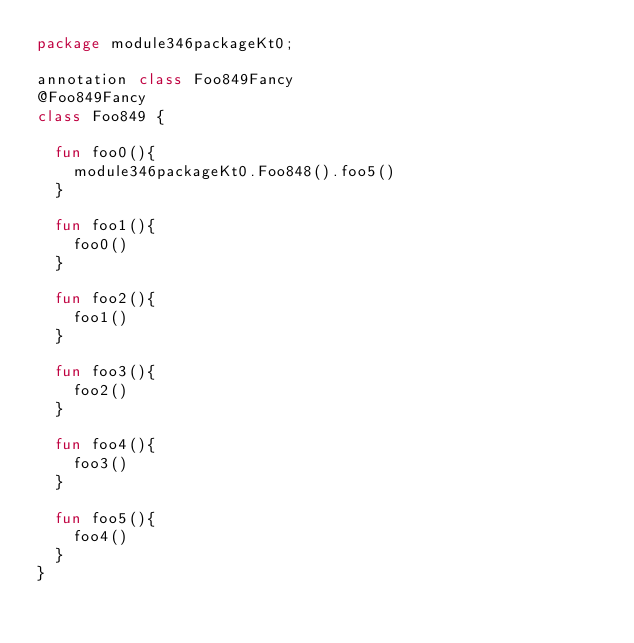<code> <loc_0><loc_0><loc_500><loc_500><_Kotlin_>package module346packageKt0;

annotation class Foo849Fancy
@Foo849Fancy
class Foo849 {

  fun foo0(){
    module346packageKt0.Foo848().foo5()
  }

  fun foo1(){
    foo0()
  }

  fun foo2(){
    foo1()
  }

  fun foo3(){
    foo2()
  }

  fun foo4(){
    foo3()
  }

  fun foo5(){
    foo4()
  }
}</code> 